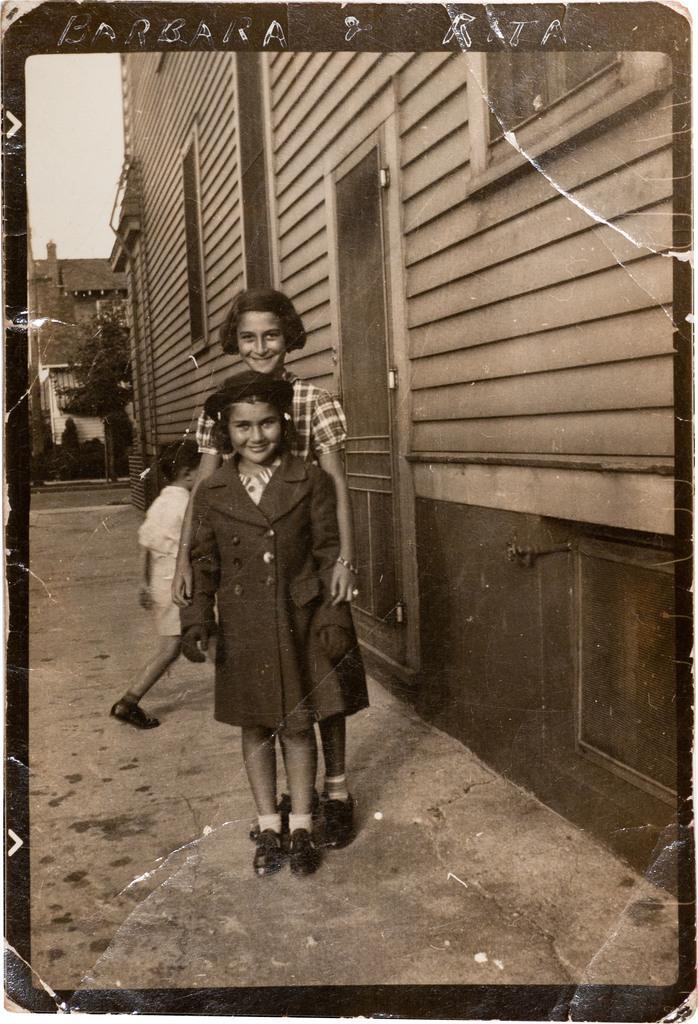How would you summarize this image in a sentence or two? This image consists of three persons. At the bottom, there is a road. On the right, we can see a building. It looks like a photograph. 